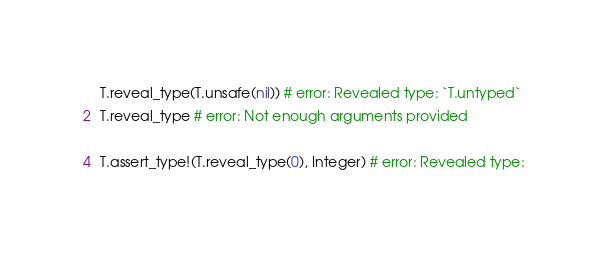Convert code to text. <code><loc_0><loc_0><loc_500><loc_500><_Ruby_>T.reveal_type(T.unsafe(nil)) # error: Revealed type: `T.untyped`
T.reveal_type # error: Not enough arguments provided

T.assert_type!(T.reveal_type(0), Integer) # error: Revealed type:
</code> 